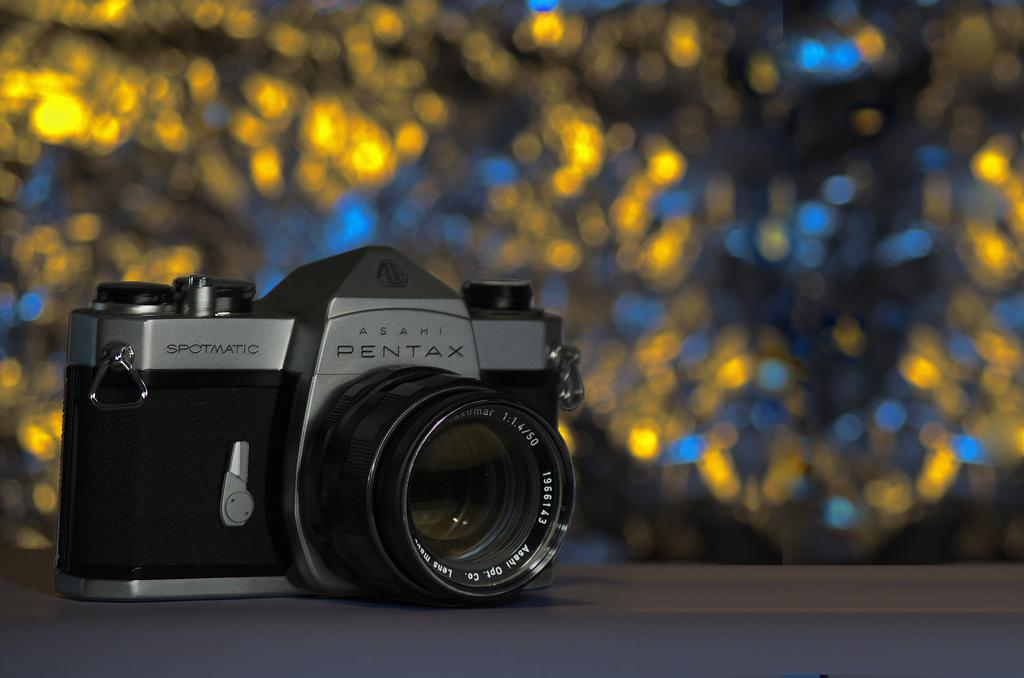What is the main subject of the image? The main subject of the image is a camera. Where is the camera located in the image? The camera is in the center of the image. What can be seen on the camera itself? There is text written on the camera. How would you describe the background of the image? The background of the image is blurry. What type of attraction is visible behind the camera in the image? There is no attraction visible behind the camera in the image; the background is blurry. What type of curtain is present in the image? There is no curtain present in the image; it features a camera with a blurry background. 